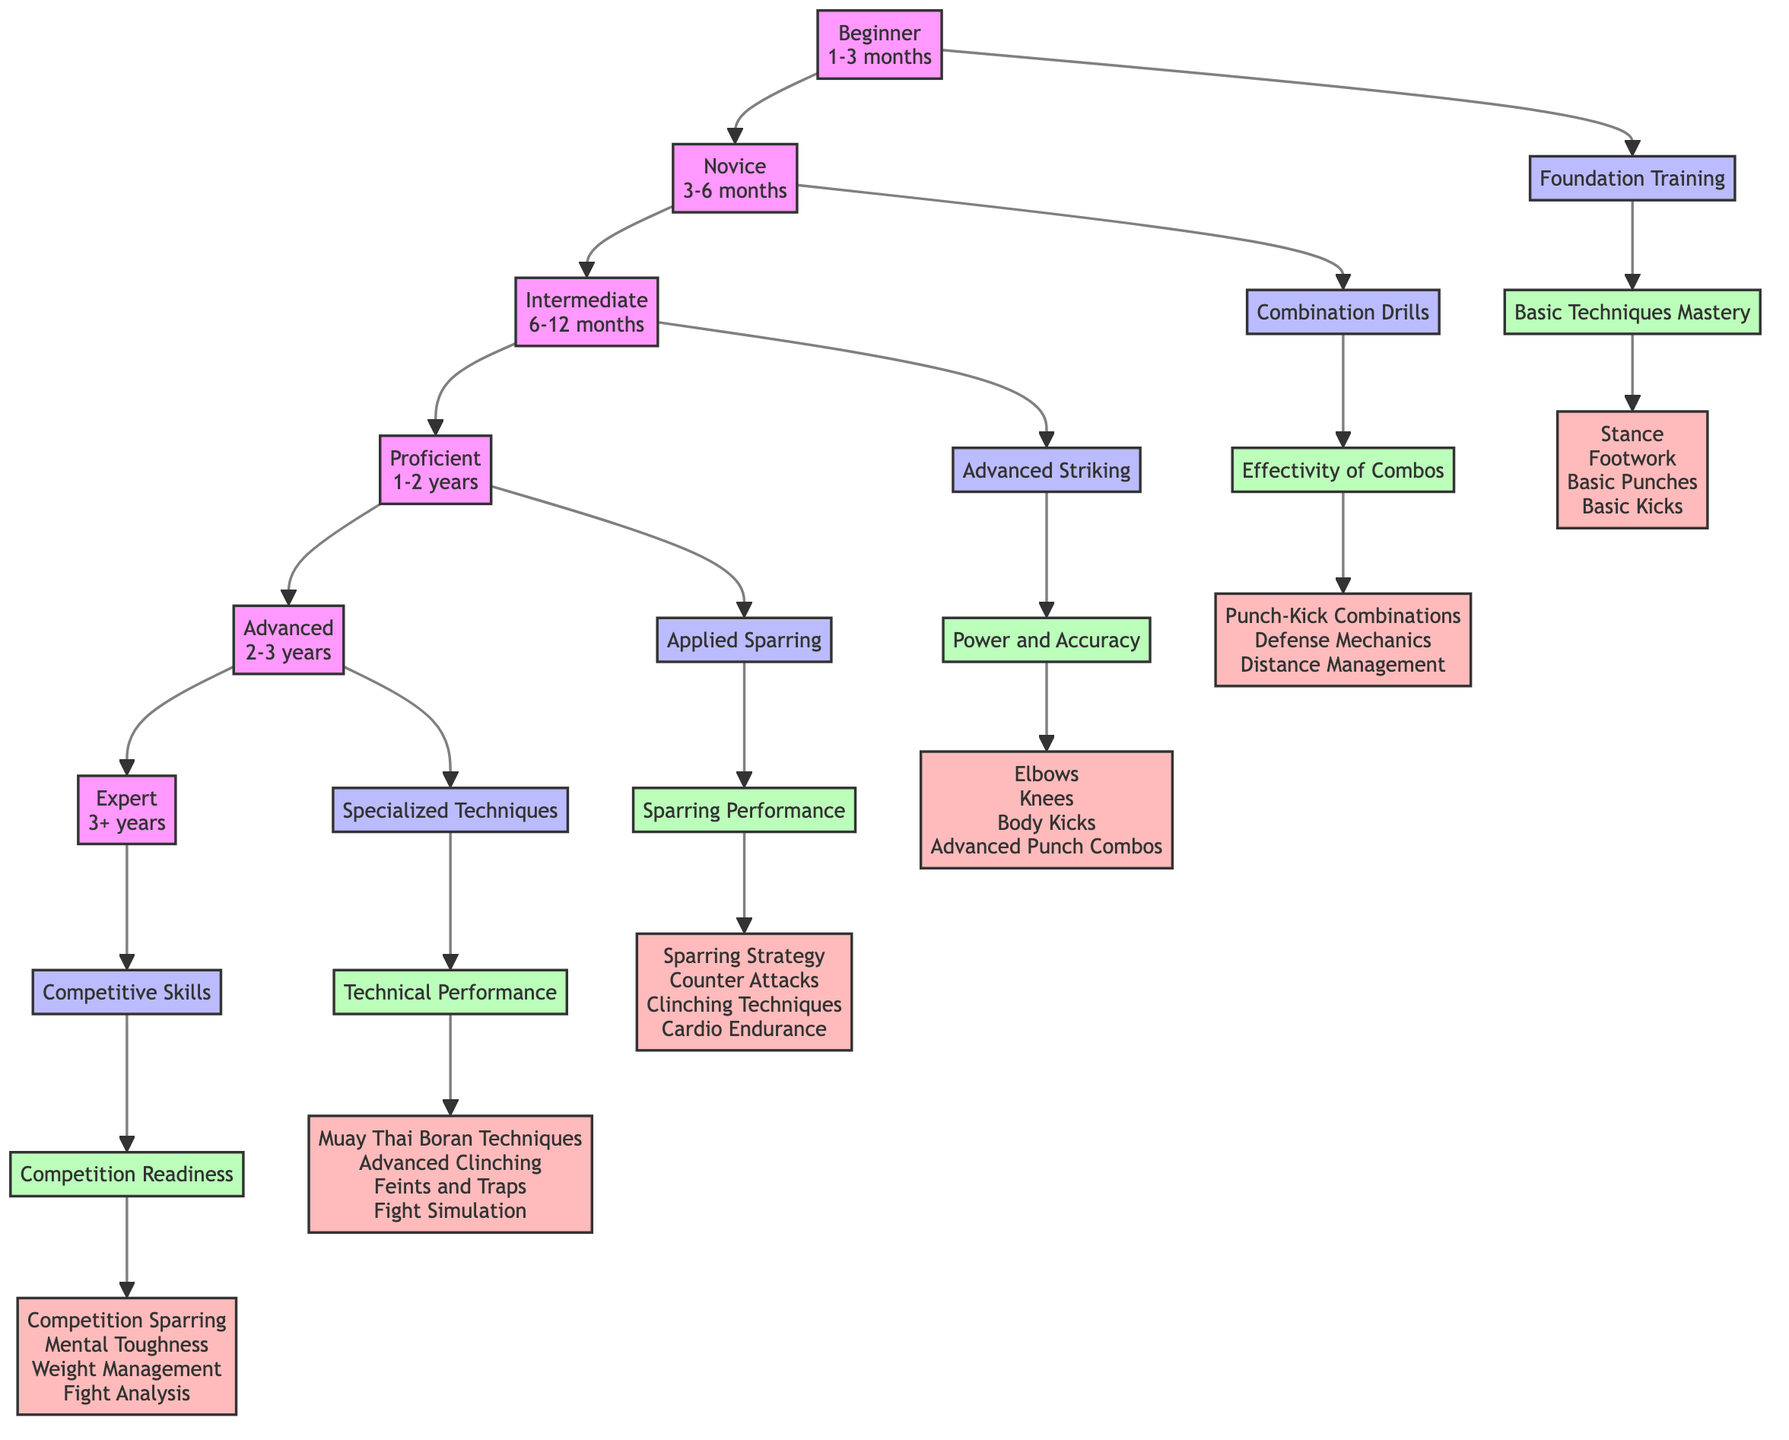What is the time frame for the Intermediate level? Referring to the diagram, the Intermediate level indicates a time frame of 6-12 months for progression.
Answer: 6-12 months What milestone corresponds to the Proficient level? The diagram shows that the Proficient level has the milestone of "Applied Sparring."
Answer: Applied Sparring How many skills are listed under the Beginner level? The diagram presents four skills under the Beginner level: Stance, Footwork, Basic Punches, and Basic Kicks, totaling four skills.
Answer: 4 What assessment follows the Novice milestone? The Novice milestone of "Combination Drills" corresponds to the assessment "Effectivity of Combos" in the diagram.
Answer: Effectivity of Combos Which level has the longest time frame? The Expert level has a time frame of 3+ years, which is longer than the time frames of the other levels indicated in the diagram.
Answer: 3+ years What type of skills are emphasized in the Advanced level? The diagram indicates that the Advanced level focuses on skills such as Muay Thai Boran Techniques, Advanced Clinching, Feints and Traps, and Fight Simulation, highlighting specialized techniques.
Answer: Specialized Techniques Which milestone is at the highest point of the flow chart? The flow chart's highest point represents the Expert level, which has the milestone of "Competitive Skills."
Answer: Competitive Skills What is the relation between the Beginner and Novice levels? The Novice level directly follows the Beginner level in the flow diagram, indicating a progression from one to the other.
Answer: Progression What type of performance does the assessment in the Intermediate level evaluate? The Intermediate level assessment evaluates "Power and Accuracy," reflecting the focus on refining striking abilities.
Answer: Power and Accuracy 